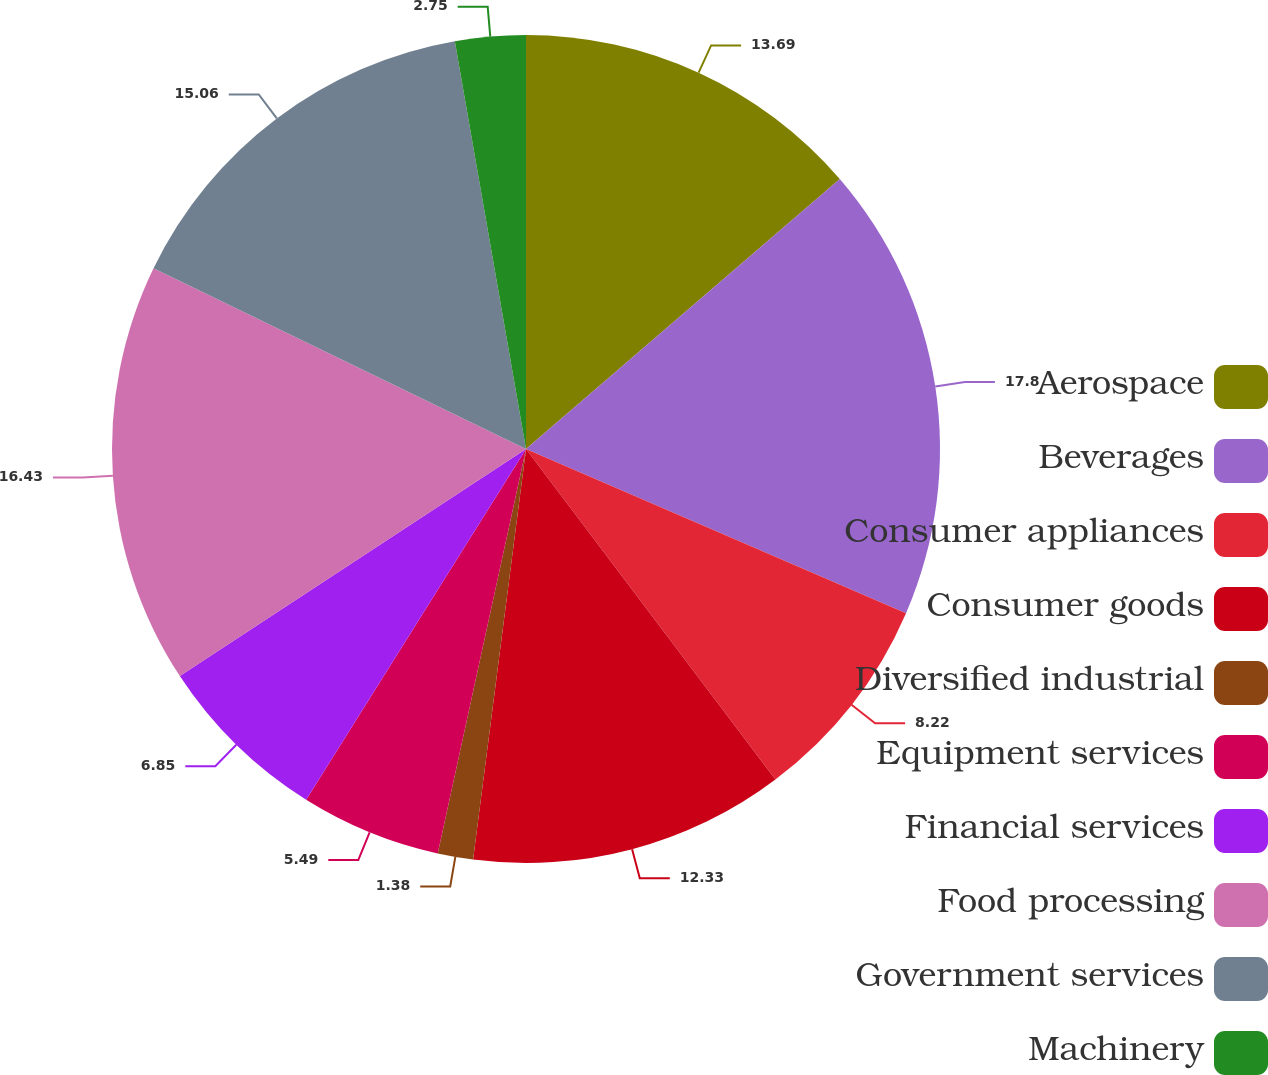Convert chart to OTSL. <chart><loc_0><loc_0><loc_500><loc_500><pie_chart><fcel>Aerospace<fcel>Beverages<fcel>Consumer appliances<fcel>Consumer goods<fcel>Diversified industrial<fcel>Equipment services<fcel>Financial services<fcel>Food processing<fcel>Government services<fcel>Machinery<nl><fcel>13.69%<fcel>17.8%<fcel>8.22%<fcel>12.33%<fcel>1.38%<fcel>5.49%<fcel>6.85%<fcel>16.43%<fcel>15.06%<fcel>2.75%<nl></chart> 